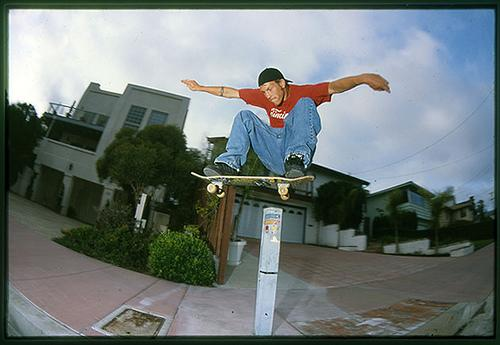Question: what type of pants is the man wearing?
Choices:
A. Slacks.
B. Sweats.
C. Khakis.
D. Jeans.
Answer with the letter. Answer: D Question: how many people are in the picture?
Choices:
A. 4.
B. 1.
C. 5.
D. 6.
Answer with the letter. Answer: B Question: what is the man doing?
Choices:
A. Surfing.
B. Parasailing.
C. Fishing.
D. Skateboarding.
Answer with the letter. Answer: D 